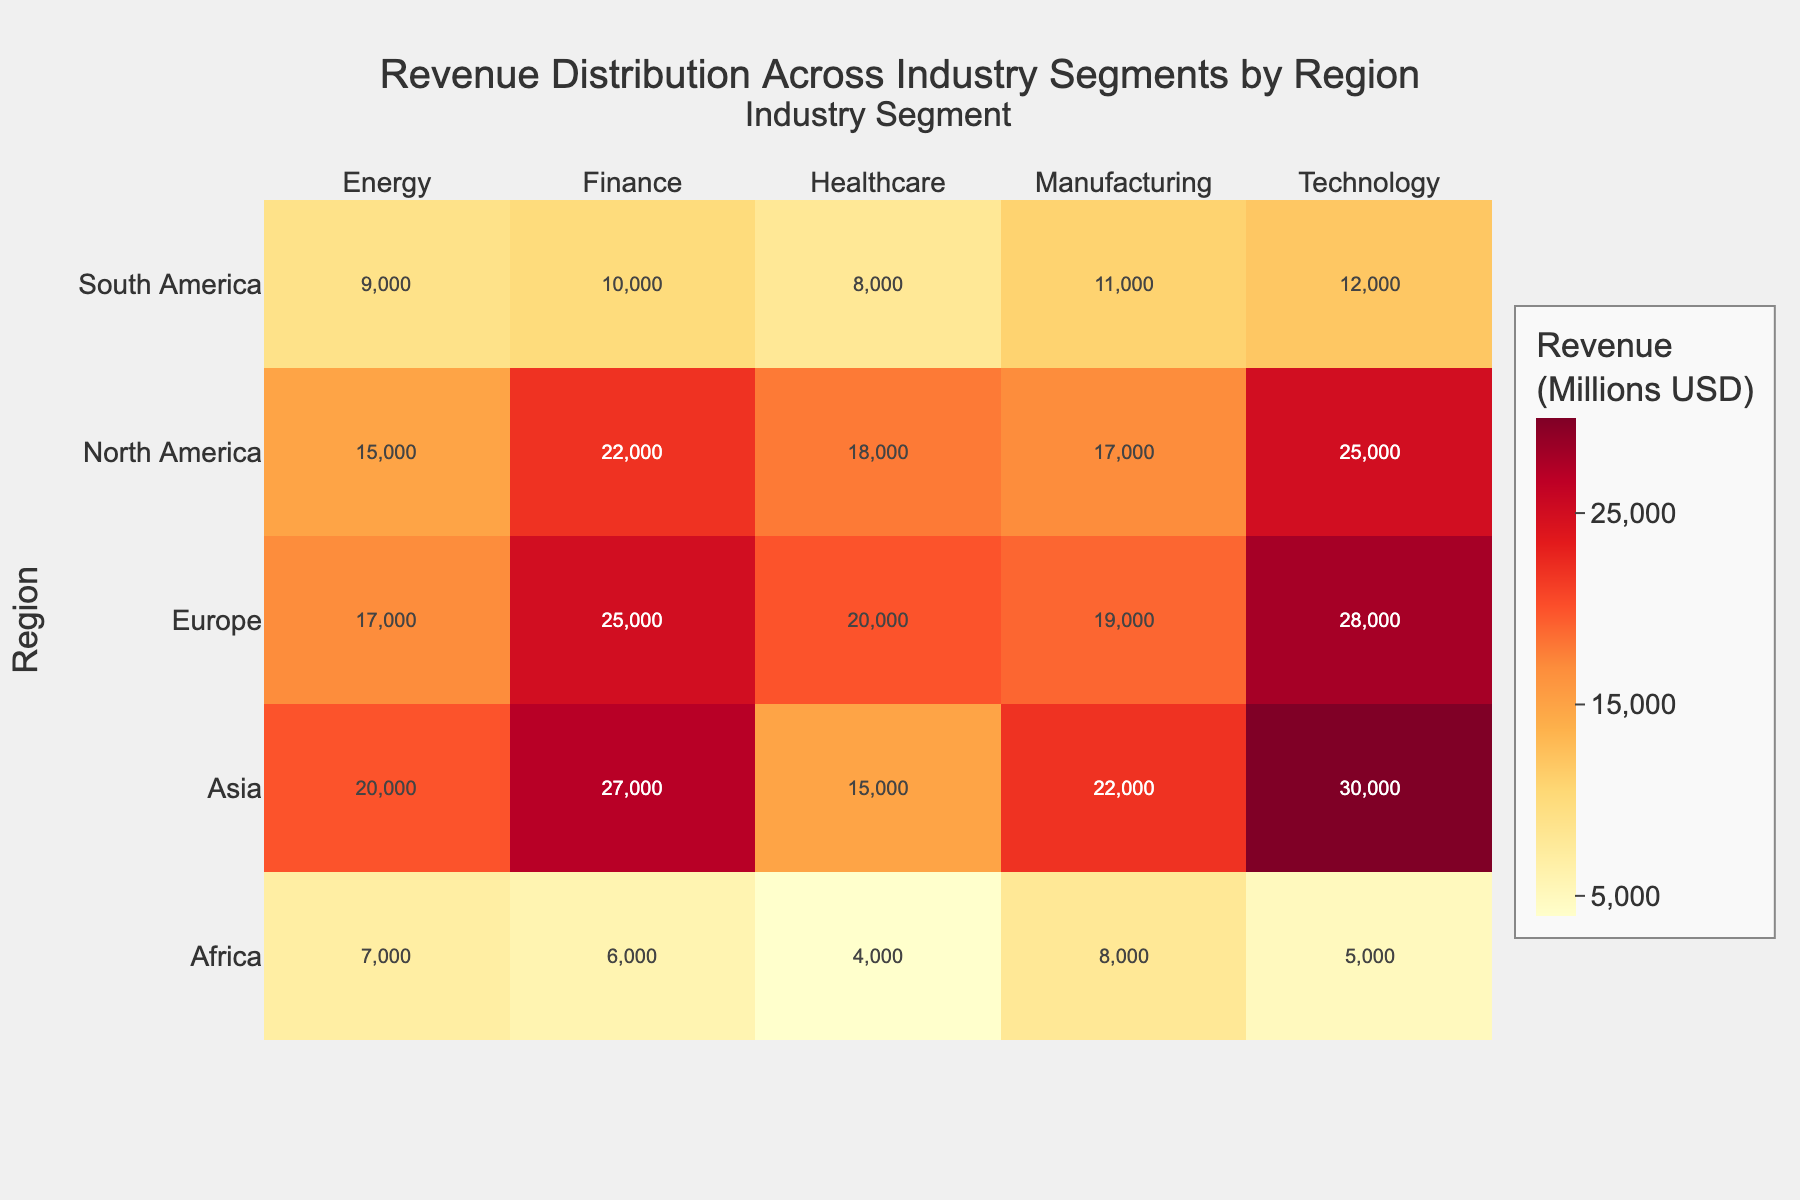What's the title of the heatmap? The title of the plot can be found at the top center of the heatmap.
Answer: Revenue Distribution Across Industry Segments by Region Which region has the highest revenue in the Technology segment? Look for the highest value in the 'Technology' column and check the corresponding row for the region.
Answer: Asia What's the difference in revenue between the Finance segment of North America and South America? Find the revenue for the Finance segment in North America and South America, then subtract the latter from the former. 22000 - 10000 = 12000
Answer: 12000 How many industry segments are displayed in the heatmap? Count the number of columns labeled as industry segments at the top of the heatmap.
Answer: 5 Which region has the lowest revenue overall across all industry segments? Observe the heatmap to identify the region where most cells have the lowest values.
Answer: Africa What's the total revenue for the Manufacturing segment across all regions? Sum up the values of the Manufacturing segment across all regions: 17000 + 11000 + 19000 + 22000 + 8000.
Answer: 77000 Which industry segment has the highest revenue in Europe? Identify the highest value within the 'Europe' row and check the corresponding column for the industry segment.
Answer: Technology Rank the regions by their total revenue in the Healthcare segment from highest to lowest. Sum the values in the Healthcare column for each region and list them in descending order: Europe, North America, Asia, South America, Africa.
Answer: Europe > North America > Asia > South America > Africa What is the average revenue of the Energy segment across all regions? Sum the Energy segment revenue for all regions and divide by the number of regions: (15000 + 9000 + 17000 + 20000 + 7000) / 5 = 68000 / 5
Answer: 13600 Which industry segment has the most uniform revenue distribution across all regions? Look for the segment where revenue values are relatively close to each other across regions.
Answer: Manufacturing 